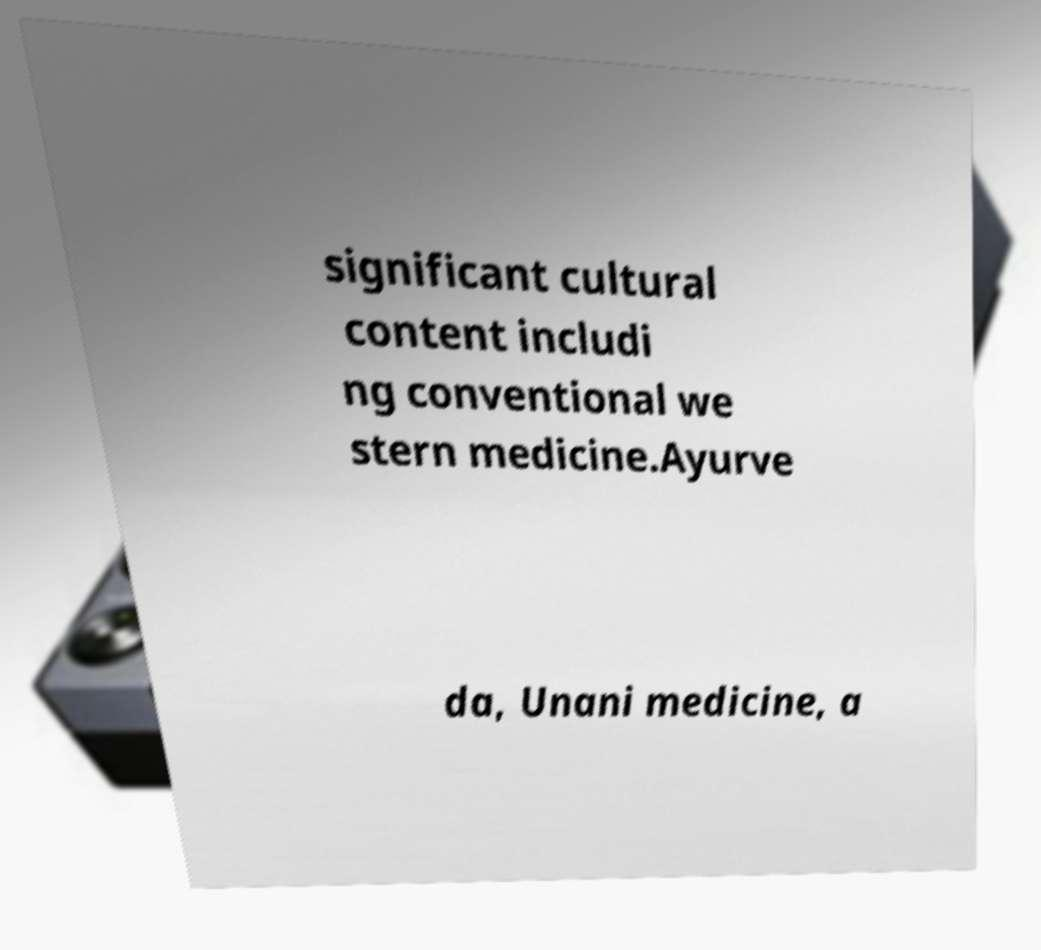For documentation purposes, I need the text within this image transcribed. Could you provide that? significant cultural content includi ng conventional we stern medicine.Ayurve da, Unani medicine, a 